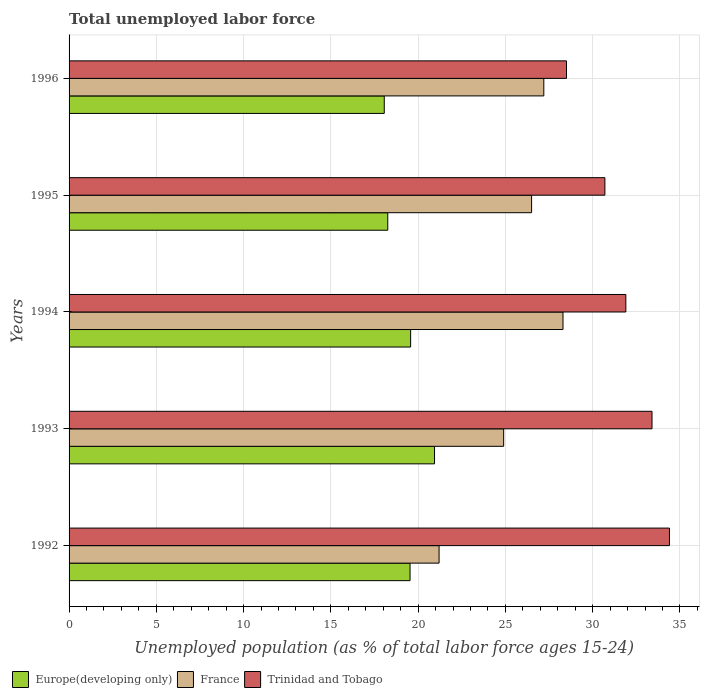How many groups of bars are there?
Your answer should be very brief. 5. Are the number of bars per tick equal to the number of legend labels?
Offer a terse response. Yes. How many bars are there on the 2nd tick from the top?
Offer a terse response. 3. What is the label of the 3rd group of bars from the top?
Your answer should be very brief. 1994. In how many cases, is the number of bars for a given year not equal to the number of legend labels?
Provide a succinct answer. 0. What is the percentage of unemployed population in in France in 1992?
Offer a very short reply. 21.2. Across all years, what is the maximum percentage of unemployed population in in Europe(developing only)?
Your answer should be very brief. 20.94. Across all years, what is the minimum percentage of unemployed population in in France?
Provide a succinct answer. 21.2. What is the total percentage of unemployed population in in France in the graph?
Your answer should be very brief. 128.1. What is the difference between the percentage of unemployed population in in Trinidad and Tobago in 1994 and that in 1995?
Offer a terse response. 1.2. What is the difference between the percentage of unemployed population in in Trinidad and Tobago in 1993 and the percentage of unemployed population in in France in 1995?
Provide a short and direct response. 6.9. What is the average percentage of unemployed population in in France per year?
Provide a succinct answer. 25.62. In the year 1993, what is the difference between the percentage of unemployed population in in France and percentage of unemployed population in in Trinidad and Tobago?
Your answer should be very brief. -8.5. In how many years, is the percentage of unemployed population in in Trinidad and Tobago greater than 34 %?
Give a very brief answer. 1. What is the ratio of the percentage of unemployed population in in France in 1995 to that in 1996?
Ensure brevity in your answer.  0.97. Is the percentage of unemployed population in in France in 1992 less than that in 1994?
Give a very brief answer. Yes. Is the difference between the percentage of unemployed population in in France in 1993 and 1996 greater than the difference between the percentage of unemployed population in in Trinidad and Tobago in 1993 and 1996?
Provide a succinct answer. No. What is the difference between the highest and the second highest percentage of unemployed population in in Europe(developing only)?
Ensure brevity in your answer.  1.37. What is the difference between the highest and the lowest percentage of unemployed population in in Europe(developing only)?
Your answer should be compact. 2.88. Is the sum of the percentage of unemployed population in in France in 1995 and 1996 greater than the maximum percentage of unemployed population in in Trinidad and Tobago across all years?
Provide a succinct answer. Yes. What does the 1st bar from the top in 1995 represents?
Offer a very short reply. Trinidad and Tobago. How many years are there in the graph?
Give a very brief answer. 5. What is the difference between two consecutive major ticks on the X-axis?
Your answer should be very brief. 5. Does the graph contain any zero values?
Keep it short and to the point. No. Where does the legend appear in the graph?
Provide a short and direct response. Bottom left. How many legend labels are there?
Provide a succinct answer. 3. How are the legend labels stacked?
Your response must be concise. Horizontal. What is the title of the graph?
Provide a succinct answer. Total unemployed labor force. What is the label or title of the X-axis?
Give a very brief answer. Unemployed population (as % of total labor force ages 15-24). What is the label or title of the Y-axis?
Keep it short and to the point. Years. What is the Unemployed population (as % of total labor force ages 15-24) of Europe(developing only) in 1992?
Ensure brevity in your answer.  19.54. What is the Unemployed population (as % of total labor force ages 15-24) in France in 1992?
Offer a terse response. 21.2. What is the Unemployed population (as % of total labor force ages 15-24) of Trinidad and Tobago in 1992?
Provide a succinct answer. 34.4. What is the Unemployed population (as % of total labor force ages 15-24) of Europe(developing only) in 1993?
Offer a very short reply. 20.94. What is the Unemployed population (as % of total labor force ages 15-24) of France in 1993?
Provide a succinct answer. 24.9. What is the Unemployed population (as % of total labor force ages 15-24) in Trinidad and Tobago in 1993?
Keep it short and to the point. 33.4. What is the Unemployed population (as % of total labor force ages 15-24) of Europe(developing only) in 1994?
Make the answer very short. 19.57. What is the Unemployed population (as % of total labor force ages 15-24) in France in 1994?
Your response must be concise. 28.3. What is the Unemployed population (as % of total labor force ages 15-24) in Trinidad and Tobago in 1994?
Offer a very short reply. 31.9. What is the Unemployed population (as % of total labor force ages 15-24) of Europe(developing only) in 1995?
Offer a very short reply. 18.26. What is the Unemployed population (as % of total labor force ages 15-24) of Trinidad and Tobago in 1995?
Offer a very short reply. 30.7. What is the Unemployed population (as % of total labor force ages 15-24) in Europe(developing only) in 1996?
Provide a short and direct response. 18.06. What is the Unemployed population (as % of total labor force ages 15-24) in France in 1996?
Your answer should be compact. 27.2. What is the Unemployed population (as % of total labor force ages 15-24) of Trinidad and Tobago in 1996?
Your answer should be very brief. 28.5. Across all years, what is the maximum Unemployed population (as % of total labor force ages 15-24) of Europe(developing only)?
Keep it short and to the point. 20.94. Across all years, what is the maximum Unemployed population (as % of total labor force ages 15-24) of France?
Provide a short and direct response. 28.3. Across all years, what is the maximum Unemployed population (as % of total labor force ages 15-24) of Trinidad and Tobago?
Ensure brevity in your answer.  34.4. Across all years, what is the minimum Unemployed population (as % of total labor force ages 15-24) of Europe(developing only)?
Offer a terse response. 18.06. Across all years, what is the minimum Unemployed population (as % of total labor force ages 15-24) of France?
Your response must be concise. 21.2. What is the total Unemployed population (as % of total labor force ages 15-24) in Europe(developing only) in the graph?
Your answer should be very brief. 96.36. What is the total Unemployed population (as % of total labor force ages 15-24) of France in the graph?
Keep it short and to the point. 128.1. What is the total Unemployed population (as % of total labor force ages 15-24) in Trinidad and Tobago in the graph?
Offer a terse response. 158.9. What is the difference between the Unemployed population (as % of total labor force ages 15-24) of Europe(developing only) in 1992 and that in 1993?
Offer a very short reply. -1.4. What is the difference between the Unemployed population (as % of total labor force ages 15-24) in Trinidad and Tobago in 1992 and that in 1993?
Make the answer very short. 1. What is the difference between the Unemployed population (as % of total labor force ages 15-24) in Europe(developing only) in 1992 and that in 1994?
Give a very brief answer. -0.03. What is the difference between the Unemployed population (as % of total labor force ages 15-24) of France in 1992 and that in 1994?
Your response must be concise. -7.1. What is the difference between the Unemployed population (as % of total labor force ages 15-24) of Trinidad and Tobago in 1992 and that in 1994?
Keep it short and to the point. 2.5. What is the difference between the Unemployed population (as % of total labor force ages 15-24) of Europe(developing only) in 1992 and that in 1995?
Keep it short and to the point. 1.28. What is the difference between the Unemployed population (as % of total labor force ages 15-24) of France in 1992 and that in 1995?
Offer a terse response. -5.3. What is the difference between the Unemployed population (as % of total labor force ages 15-24) in Europe(developing only) in 1992 and that in 1996?
Your response must be concise. 1.48. What is the difference between the Unemployed population (as % of total labor force ages 15-24) of Europe(developing only) in 1993 and that in 1994?
Provide a short and direct response. 1.37. What is the difference between the Unemployed population (as % of total labor force ages 15-24) in Trinidad and Tobago in 1993 and that in 1994?
Provide a succinct answer. 1.5. What is the difference between the Unemployed population (as % of total labor force ages 15-24) in Europe(developing only) in 1993 and that in 1995?
Provide a succinct answer. 2.68. What is the difference between the Unemployed population (as % of total labor force ages 15-24) of Trinidad and Tobago in 1993 and that in 1995?
Ensure brevity in your answer.  2.7. What is the difference between the Unemployed population (as % of total labor force ages 15-24) of Europe(developing only) in 1993 and that in 1996?
Your answer should be very brief. 2.88. What is the difference between the Unemployed population (as % of total labor force ages 15-24) in Europe(developing only) in 1994 and that in 1995?
Offer a very short reply. 1.31. What is the difference between the Unemployed population (as % of total labor force ages 15-24) in France in 1994 and that in 1995?
Your response must be concise. 1.8. What is the difference between the Unemployed population (as % of total labor force ages 15-24) in Europe(developing only) in 1994 and that in 1996?
Offer a terse response. 1.51. What is the difference between the Unemployed population (as % of total labor force ages 15-24) of France in 1994 and that in 1996?
Your answer should be very brief. 1.1. What is the difference between the Unemployed population (as % of total labor force ages 15-24) of Trinidad and Tobago in 1994 and that in 1996?
Your answer should be compact. 3.4. What is the difference between the Unemployed population (as % of total labor force ages 15-24) of Europe(developing only) in 1995 and that in 1996?
Ensure brevity in your answer.  0.2. What is the difference between the Unemployed population (as % of total labor force ages 15-24) in Europe(developing only) in 1992 and the Unemployed population (as % of total labor force ages 15-24) in France in 1993?
Make the answer very short. -5.36. What is the difference between the Unemployed population (as % of total labor force ages 15-24) of Europe(developing only) in 1992 and the Unemployed population (as % of total labor force ages 15-24) of Trinidad and Tobago in 1993?
Provide a succinct answer. -13.86. What is the difference between the Unemployed population (as % of total labor force ages 15-24) of Europe(developing only) in 1992 and the Unemployed population (as % of total labor force ages 15-24) of France in 1994?
Your response must be concise. -8.76. What is the difference between the Unemployed population (as % of total labor force ages 15-24) in Europe(developing only) in 1992 and the Unemployed population (as % of total labor force ages 15-24) in Trinidad and Tobago in 1994?
Give a very brief answer. -12.36. What is the difference between the Unemployed population (as % of total labor force ages 15-24) of Europe(developing only) in 1992 and the Unemployed population (as % of total labor force ages 15-24) of France in 1995?
Offer a very short reply. -6.96. What is the difference between the Unemployed population (as % of total labor force ages 15-24) of Europe(developing only) in 1992 and the Unemployed population (as % of total labor force ages 15-24) of Trinidad and Tobago in 1995?
Make the answer very short. -11.16. What is the difference between the Unemployed population (as % of total labor force ages 15-24) of Europe(developing only) in 1992 and the Unemployed population (as % of total labor force ages 15-24) of France in 1996?
Make the answer very short. -7.66. What is the difference between the Unemployed population (as % of total labor force ages 15-24) in Europe(developing only) in 1992 and the Unemployed population (as % of total labor force ages 15-24) in Trinidad and Tobago in 1996?
Your answer should be compact. -8.96. What is the difference between the Unemployed population (as % of total labor force ages 15-24) in Europe(developing only) in 1993 and the Unemployed population (as % of total labor force ages 15-24) in France in 1994?
Offer a terse response. -7.36. What is the difference between the Unemployed population (as % of total labor force ages 15-24) of Europe(developing only) in 1993 and the Unemployed population (as % of total labor force ages 15-24) of Trinidad and Tobago in 1994?
Offer a very short reply. -10.96. What is the difference between the Unemployed population (as % of total labor force ages 15-24) in France in 1993 and the Unemployed population (as % of total labor force ages 15-24) in Trinidad and Tobago in 1994?
Make the answer very short. -7. What is the difference between the Unemployed population (as % of total labor force ages 15-24) in Europe(developing only) in 1993 and the Unemployed population (as % of total labor force ages 15-24) in France in 1995?
Provide a succinct answer. -5.56. What is the difference between the Unemployed population (as % of total labor force ages 15-24) in Europe(developing only) in 1993 and the Unemployed population (as % of total labor force ages 15-24) in Trinidad and Tobago in 1995?
Keep it short and to the point. -9.76. What is the difference between the Unemployed population (as % of total labor force ages 15-24) of Europe(developing only) in 1993 and the Unemployed population (as % of total labor force ages 15-24) of France in 1996?
Give a very brief answer. -6.26. What is the difference between the Unemployed population (as % of total labor force ages 15-24) in Europe(developing only) in 1993 and the Unemployed population (as % of total labor force ages 15-24) in Trinidad and Tobago in 1996?
Your response must be concise. -7.56. What is the difference between the Unemployed population (as % of total labor force ages 15-24) of France in 1993 and the Unemployed population (as % of total labor force ages 15-24) of Trinidad and Tobago in 1996?
Provide a short and direct response. -3.6. What is the difference between the Unemployed population (as % of total labor force ages 15-24) in Europe(developing only) in 1994 and the Unemployed population (as % of total labor force ages 15-24) in France in 1995?
Your answer should be compact. -6.93. What is the difference between the Unemployed population (as % of total labor force ages 15-24) of Europe(developing only) in 1994 and the Unemployed population (as % of total labor force ages 15-24) of Trinidad and Tobago in 1995?
Offer a terse response. -11.13. What is the difference between the Unemployed population (as % of total labor force ages 15-24) in France in 1994 and the Unemployed population (as % of total labor force ages 15-24) in Trinidad and Tobago in 1995?
Your response must be concise. -2.4. What is the difference between the Unemployed population (as % of total labor force ages 15-24) in Europe(developing only) in 1994 and the Unemployed population (as % of total labor force ages 15-24) in France in 1996?
Provide a short and direct response. -7.63. What is the difference between the Unemployed population (as % of total labor force ages 15-24) of Europe(developing only) in 1994 and the Unemployed population (as % of total labor force ages 15-24) of Trinidad and Tobago in 1996?
Provide a succinct answer. -8.93. What is the difference between the Unemployed population (as % of total labor force ages 15-24) of Europe(developing only) in 1995 and the Unemployed population (as % of total labor force ages 15-24) of France in 1996?
Provide a succinct answer. -8.94. What is the difference between the Unemployed population (as % of total labor force ages 15-24) of Europe(developing only) in 1995 and the Unemployed population (as % of total labor force ages 15-24) of Trinidad and Tobago in 1996?
Your answer should be compact. -10.24. What is the difference between the Unemployed population (as % of total labor force ages 15-24) of France in 1995 and the Unemployed population (as % of total labor force ages 15-24) of Trinidad and Tobago in 1996?
Give a very brief answer. -2. What is the average Unemployed population (as % of total labor force ages 15-24) of Europe(developing only) per year?
Keep it short and to the point. 19.27. What is the average Unemployed population (as % of total labor force ages 15-24) in France per year?
Give a very brief answer. 25.62. What is the average Unemployed population (as % of total labor force ages 15-24) in Trinidad and Tobago per year?
Give a very brief answer. 31.78. In the year 1992, what is the difference between the Unemployed population (as % of total labor force ages 15-24) in Europe(developing only) and Unemployed population (as % of total labor force ages 15-24) in France?
Provide a short and direct response. -1.66. In the year 1992, what is the difference between the Unemployed population (as % of total labor force ages 15-24) in Europe(developing only) and Unemployed population (as % of total labor force ages 15-24) in Trinidad and Tobago?
Your response must be concise. -14.86. In the year 1993, what is the difference between the Unemployed population (as % of total labor force ages 15-24) of Europe(developing only) and Unemployed population (as % of total labor force ages 15-24) of France?
Ensure brevity in your answer.  -3.96. In the year 1993, what is the difference between the Unemployed population (as % of total labor force ages 15-24) of Europe(developing only) and Unemployed population (as % of total labor force ages 15-24) of Trinidad and Tobago?
Your answer should be very brief. -12.46. In the year 1993, what is the difference between the Unemployed population (as % of total labor force ages 15-24) of France and Unemployed population (as % of total labor force ages 15-24) of Trinidad and Tobago?
Provide a short and direct response. -8.5. In the year 1994, what is the difference between the Unemployed population (as % of total labor force ages 15-24) in Europe(developing only) and Unemployed population (as % of total labor force ages 15-24) in France?
Offer a very short reply. -8.73. In the year 1994, what is the difference between the Unemployed population (as % of total labor force ages 15-24) of Europe(developing only) and Unemployed population (as % of total labor force ages 15-24) of Trinidad and Tobago?
Ensure brevity in your answer.  -12.33. In the year 1995, what is the difference between the Unemployed population (as % of total labor force ages 15-24) in Europe(developing only) and Unemployed population (as % of total labor force ages 15-24) in France?
Your answer should be very brief. -8.24. In the year 1995, what is the difference between the Unemployed population (as % of total labor force ages 15-24) in Europe(developing only) and Unemployed population (as % of total labor force ages 15-24) in Trinidad and Tobago?
Keep it short and to the point. -12.44. In the year 1995, what is the difference between the Unemployed population (as % of total labor force ages 15-24) in France and Unemployed population (as % of total labor force ages 15-24) in Trinidad and Tobago?
Provide a succinct answer. -4.2. In the year 1996, what is the difference between the Unemployed population (as % of total labor force ages 15-24) of Europe(developing only) and Unemployed population (as % of total labor force ages 15-24) of France?
Your response must be concise. -9.14. In the year 1996, what is the difference between the Unemployed population (as % of total labor force ages 15-24) in Europe(developing only) and Unemployed population (as % of total labor force ages 15-24) in Trinidad and Tobago?
Your answer should be very brief. -10.44. In the year 1996, what is the difference between the Unemployed population (as % of total labor force ages 15-24) in France and Unemployed population (as % of total labor force ages 15-24) in Trinidad and Tobago?
Give a very brief answer. -1.3. What is the ratio of the Unemployed population (as % of total labor force ages 15-24) in Europe(developing only) in 1992 to that in 1993?
Your answer should be very brief. 0.93. What is the ratio of the Unemployed population (as % of total labor force ages 15-24) of France in 1992 to that in 1993?
Ensure brevity in your answer.  0.85. What is the ratio of the Unemployed population (as % of total labor force ages 15-24) in Trinidad and Tobago in 1992 to that in 1993?
Ensure brevity in your answer.  1.03. What is the ratio of the Unemployed population (as % of total labor force ages 15-24) of France in 1992 to that in 1994?
Give a very brief answer. 0.75. What is the ratio of the Unemployed population (as % of total labor force ages 15-24) of Trinidad and Tobago in 1992 to that in 1994?
Provide a succinct answer. 1.08. What is the ratio of the Unemployed population (as % of total labor force ages 15-24) in Europe(developing only) in 1992 to that in 1995?
Your answer should be compact. 1.07. What is the ratio of the Unemployed population (as % of total labor force ages 15-24) of France in 1992 to that in 1995?
Ensure brevity in your answer.  0.8. What is the ratio of the Unemployed population (as % of total labor force ages 15-24) in Trinidad and Tobago in 1992 to that in 1995?
Provide a short and direct response. 1.12. What is the ratio of the Unemployed population (as % of total labor force ages 15-24) of Europe(developing only) in 1992 to that in 1996?
Your answer should be compact. 1.08. What is the ratio of the Unemployed population (as % of total labor force ages 15-24) in France in 1992 to that in 1996?
Your answer should be very brief. 0.78. What is the ratio of the Unemployed population (as % of total labor force ages 15-24) of Trinidad and Tobago in 1992 to that in 1996?
Ensure brevity in your answer.  1.21. What is the ratio of the Unemployed population (as % of total labor force ages 15-24) in Europe(developing only) in 1993 to that in 1994?
Your answer should be very brief. 1.07. What is the ratio of the Unemployed population (as % of total labor force ages 15-24) of France in 1993 to that in 1994?
Provide a short and direct response. 0.88. What is the ratio of the Unemployed population (as % of total labor force ages 15-24) in Trinidad and Tobago in 1993 to that in 1994?
Provide a short and direct response. 1.05. What is the ratio of the Unemployed population (as % of total labor force ages 15-24) in Europe(developing only) in 1993 to that in 1995?
Provide a short and direct response. 1.15. What is the ratio of the Unemployed population (as % of total labor force ages 15-24) of France in 1993 to that in 1995?
Offer a very short reply. 0.94. What is the ratio of the Unemployed population (as % of total labor force ages 15-24) of Trinidad and Tobago in 1993 to that in 1995?
Your answer should be compact. 1.09. What is the ratio of the Unemployed population (as % of total labor force ages 15-24) of Europe(developing only) in 1993 to that in 1996?
Give a very brief answer. 1.16. What is the ratio of the Unemployed population (as % of total labor force ages 15-24) of France in 1993 to that in 1996?
Make the answer very short. 0.92. What is the ratio of the Unemployed population (as % of total labor force ages 15-24) of Trinidad and Tobago in 1993 to that in 1996?
Ensure brevity in your answer.  1.17. What is the ratio of the Unemployed population (as % of total labor force ages 15-24) in Europe(developing only) in 1994 to that in 1995?
Offer a very short reply. 1.07. What is the ratio of the Unemployed population (as % of total labor force ages 15-24) of France in 1994 to that in 1995?
Offer a terse response. 1.07. What is the ratio of the Unemployed population (as % of total labor force ages 15-24) of Trinidad and Tobago in 1994 to that in 1995?
Offer a very short reply. 1.04. What is the ratio of the Unemployed population (as % of total labor force ages 15-24) of Europe(developing only) in 1994 to that in 1996?
Make the answer very short. 1.08. What is the ratio of the Unemployed population (as % of total labor force ages 15-24) of France in 1994 to that in 1996?
Keep it short and to the point. 1.04. What is the ratio of the Unemployed population (as % of total labor force ages 15-24) of Trinidad and Tobago in 1994 to that in 1996?
Offer a very short reply. 1.12. What is the ratio of the Unemployed population (as % of total labor force ages 15-24) in Europe(developing only) in 1995 to that in 1996?
Your answer should be very brief. 1.01. What is the ratio of the Unemployed population (as % of total labor force ages 15-24) in France in 1995 to that in 1996?
Offer a terse response. 0.97. What is the ratio of the Unemployed population (as % of total labor force ages 15-24) of Trinidad and Tobago in 1995 to that in 1996?
Offer a very short reply. 1.08. What is the difference between the highest and the second highest Unemployed population (as % of total labor force ages 15-24) of Europe(developing only)?
Offer a very short reply. 1.37. What is the difference between the highest and the second highest Unemployed population (as % of total labor force ages 15-24) in Trinidad and Tobago?
Offer a very short reply. 1. What is the difference between the highest and the lowest Unemployed population (as % of total labor force ages 15-24) of Europe(developing only)?
Your answer should be compact. 2.88. What is the difference between the highest and the lowest Unemployed population (as % of total labor force ages 15-24) in Trinidad and Tobago?
Keep it short and to the point. 5.9. 